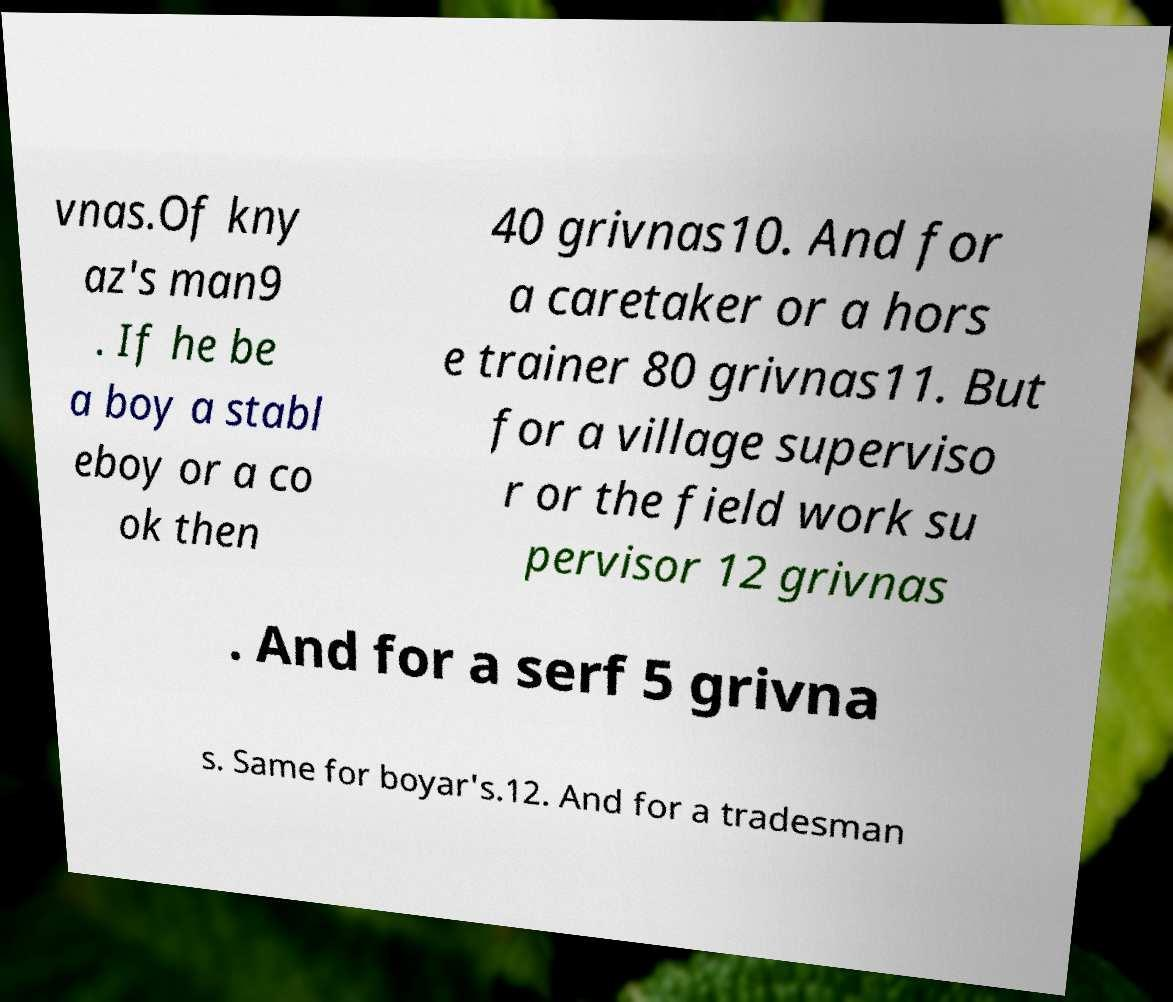Please identify and transcribe the text found in this image. vnas.Of kny az's man9 . If he be a boy a stabl eboy or a co ok then 40 grivnas10. And for a caretaker or a hors e trainer 80 grivnas11. But for a village superviso r or the field work su pervisor 12 grivnas . And for a serf 5 grivna s. Same for boyar's.12. And for a tradesman 